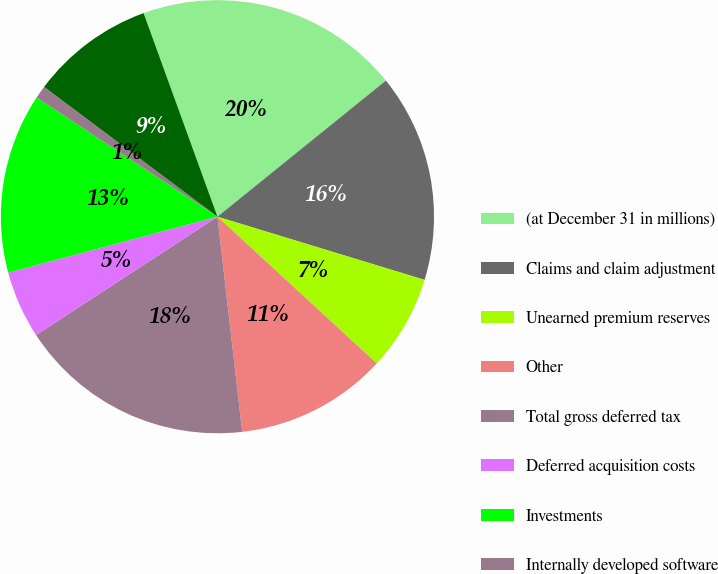Convert chart to OTSL. <chart><loc_0><loc_0><loc_500><loc_500><pie_chart><fcel>(at December 31 in millions)<fcel>Claims and claim adjustment<fcel>Unearned premium reserves<fcel>Other<fcel>Total gross deferred tax<fcel>Deferred acquisition costs<fcel>Investments<fcel>Internally developed software<fcel>Total deferred income taxes<nl><fcel>19.72%<fcel>15.53%<fcel>7.13%<fcel>11.33%<fcel>17.62%<fcel>5.04%<fcel>13.43%<fcel>0.96%<fcel>9.23%<nl></chart> 